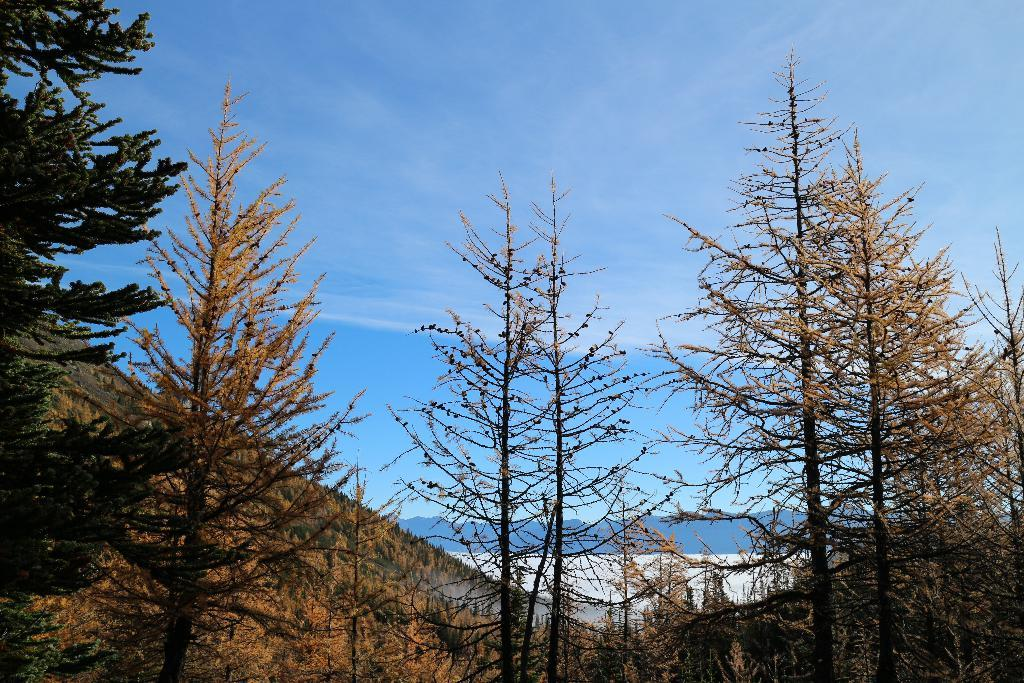What type of vegetation can be seen in the image? There are trees in the image. What can be seen in the background of the image? There are hills visible in the background of the image. What is visible in the sky in the image? The sky is visible in the image. What is present in the sky in the image? Clouds are present in the sky. What type of smell can be detected in the image? There is no reference to a smell in the image, so it is not possible to determine what type of smell might be present. What is the size of the clouds in the image? The size of the clouds cannot be determined from the image alone, as it depends on the distance and perspective of the viewer. 